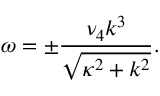Convert formula to latex. <formula><loc_0><loc_0><loc_500><loc_500>\omega = \pm \frac { \nu _ { 4 } k ^ { 3 } } { \sqrt { \kappa ^ { 2 } + k ^ { 2 } } } .</formula> 